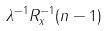Convert formula to latex. <formula><loc_0><loc_0><loc_500><loc_500>\lambda ^ { - 1 } R _ { x } ^ { - 1 } ( n - 1 )</formula> 